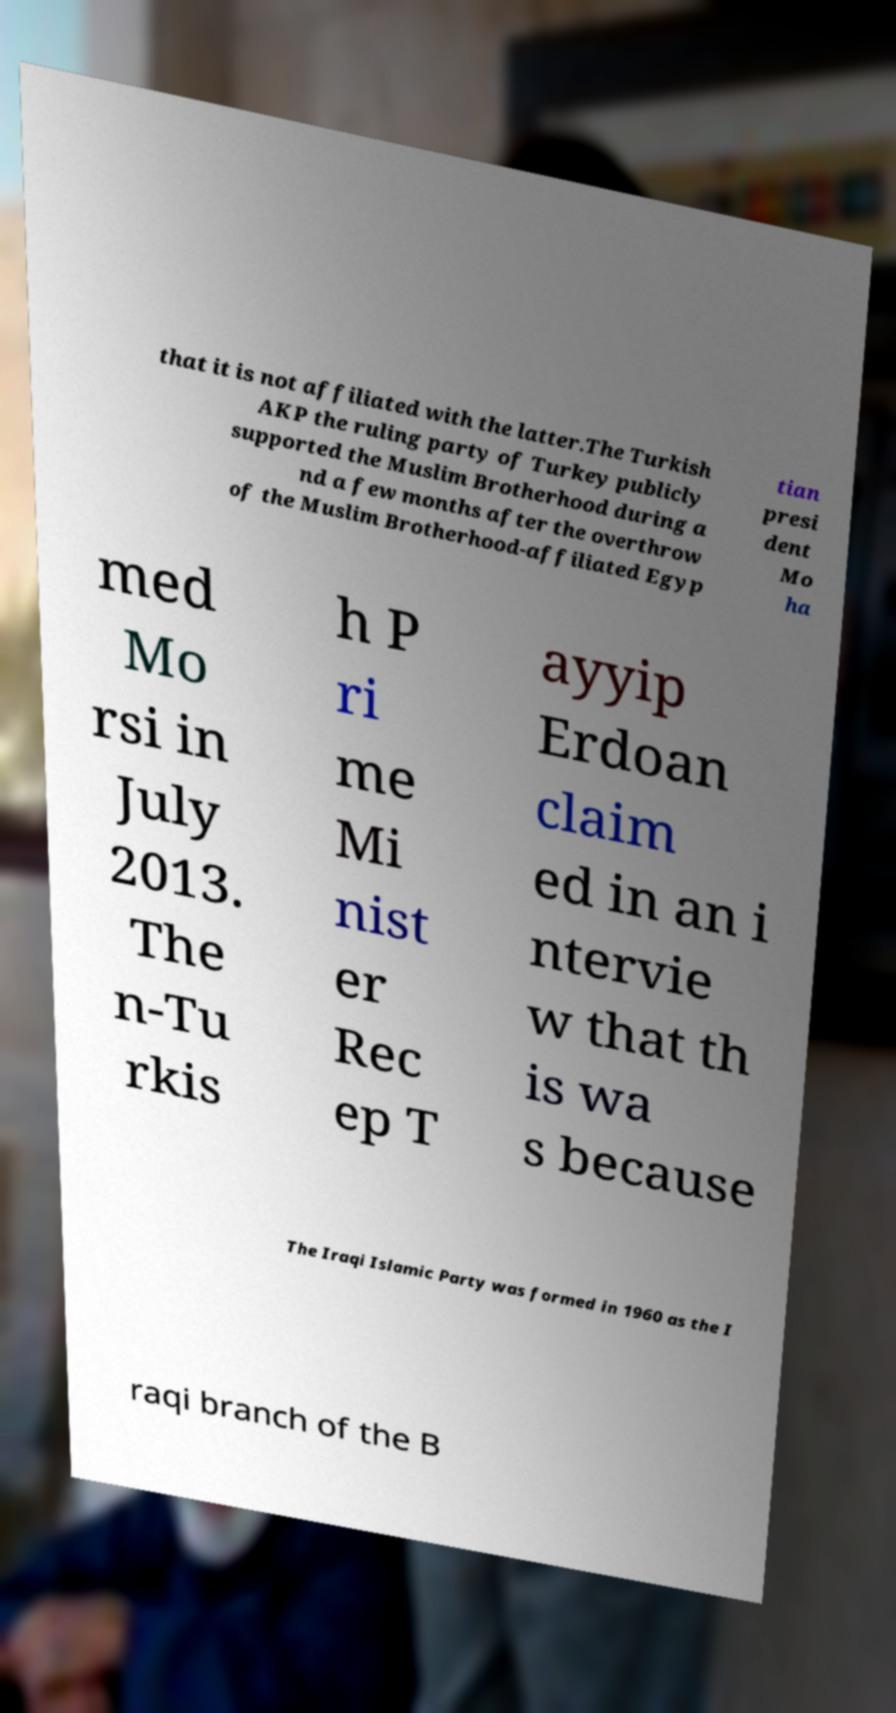Could you assist in decoding the text presented in this image and type it out clearly? that it is not affiliated with the latter.The Turkish AKP the ruling party of Turkey publicly supported the Muslim Brotherhood during a nd a few months after the overthrow of the Muslim Brotherhood-affiliated Egyp tian presi dent Mo ha med Mo rsi in July 2013. The n-Tu rkis h P ri me Mi nist er Rec ep T ayyip Erdoan claim ed in an i ntervie w that th is wa s because The Iraqi Islamic Party was formed in 1960 as the I raqi branch of the B 